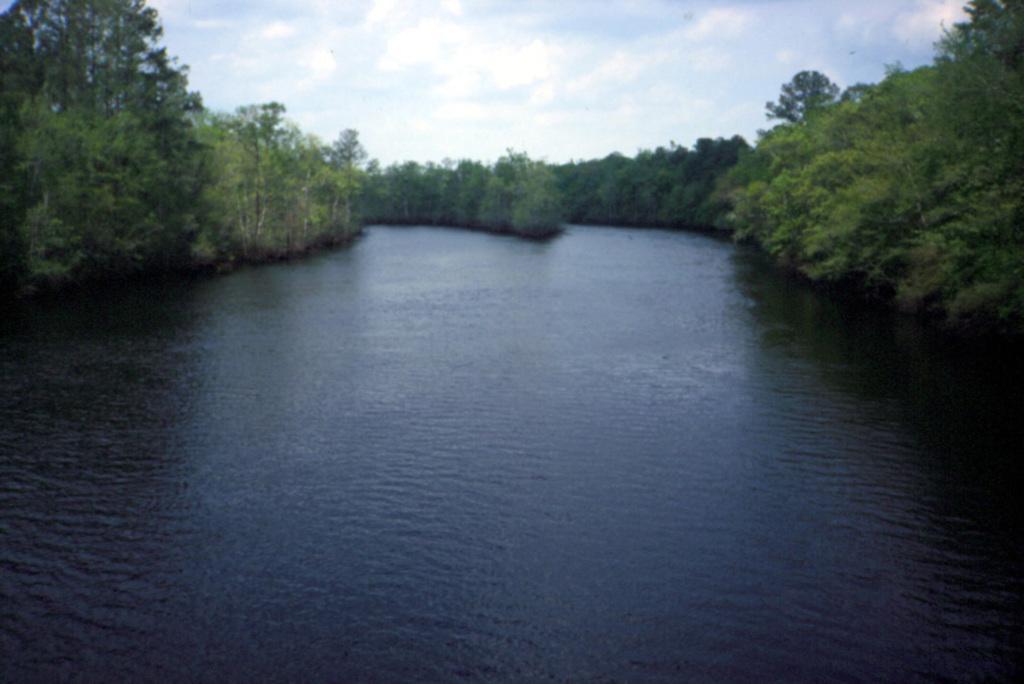How would you summarize this image in a sentence or two? In the picture we can see water and around it we can see, full of plants and trees and in the background we can see a sky with clouds. 